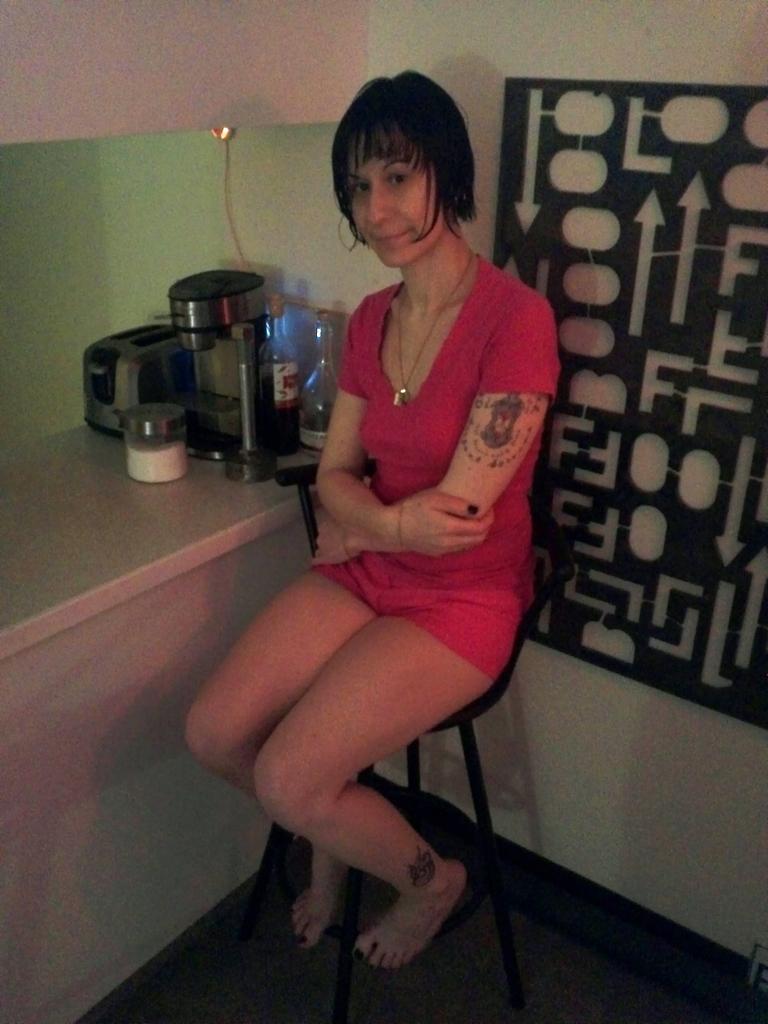Please provide a concise description of this image. In this image I can see a woman is sitting. I can see she is wearing necklace and red dress. In the background I can see few bottles and few other stuffs. 